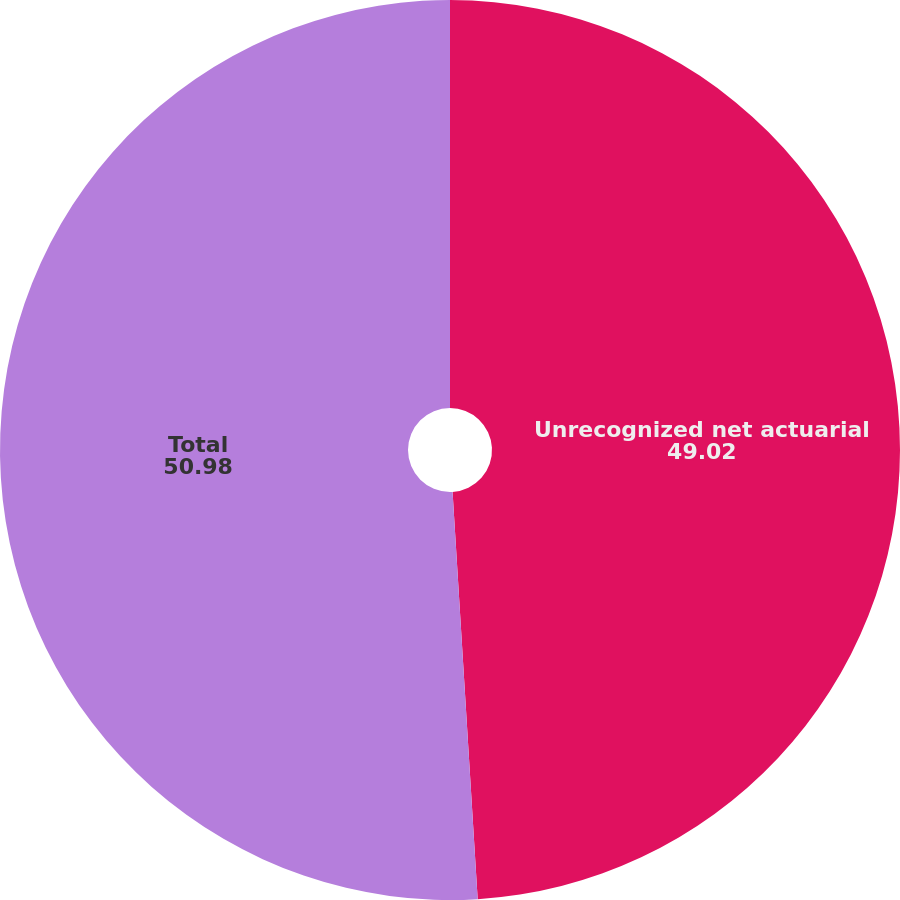<chart> <loc_0><loc_0><loc_500><loc_500><pie_chart><fcel>Unrecognized net actuarial<fcel>Total<nl><fcel>49.02%<fcel>50.98%<nl></chart> 